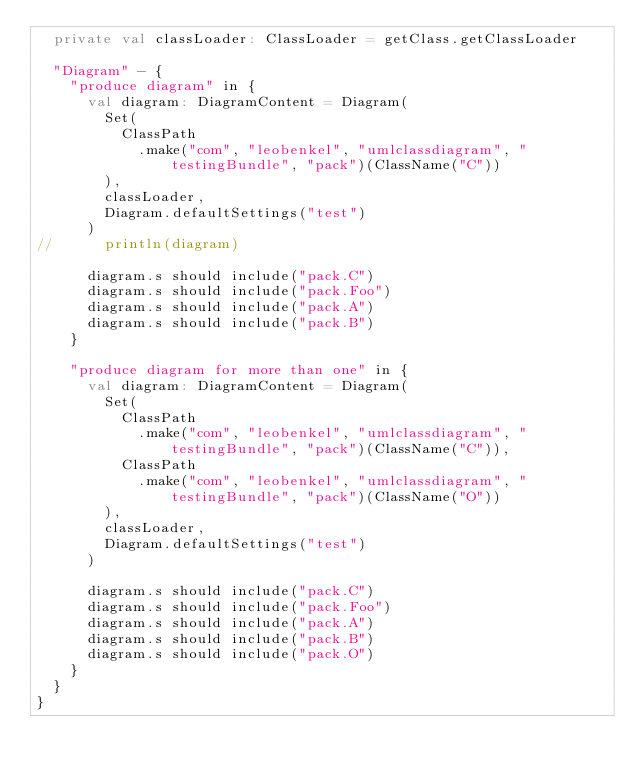<code> <loc_0><loc_0><loc_500><loc_500><_Scala_>  private val classLoader: ClassLoader = getClass.getClassLoader

  "Diagram" - {
    "produce diagram" in {
      val diagram: DiagramContent = Diagram(
        Set(
          ClassPath
            .make("com", "leobenkel", "umlclassdiagram", "testingBundle", "pack")(ClassName("C"))
        ),
        classLoader,
        Diagram.defaultSettings("test")
      )
//      println(diagram)

      diagram.s should include("pack.C")
      diagram.s should include("pack.Foo")
      diagram.s should include("pack.A")
      diagram.s should include("pack.B")
    }

    "produce diagram for more than one" in {
      val diagram: DiagramContent = Diagram(
        Set(
          ClassPath
            .make("com", "leobenkel", "umlclassdiagram", "testingBundle", "pack")(ClassName("C")),
          ClassPath
            .make("com", "leobenkel", "umlclassdiagram", "testingBundle", "pack")(ClassName("O"))
        ),
        classLoader,
        Diagram.defaultSettings("test")
      )

      diagram.s should include("pack.C")
      diagram.s should include("pack.Foo")
      diagram.s should include("pack.A")
      diagram.s should include("pack.B")
      diagram.s should include("pack.O")
    }
  }
}
</code> 